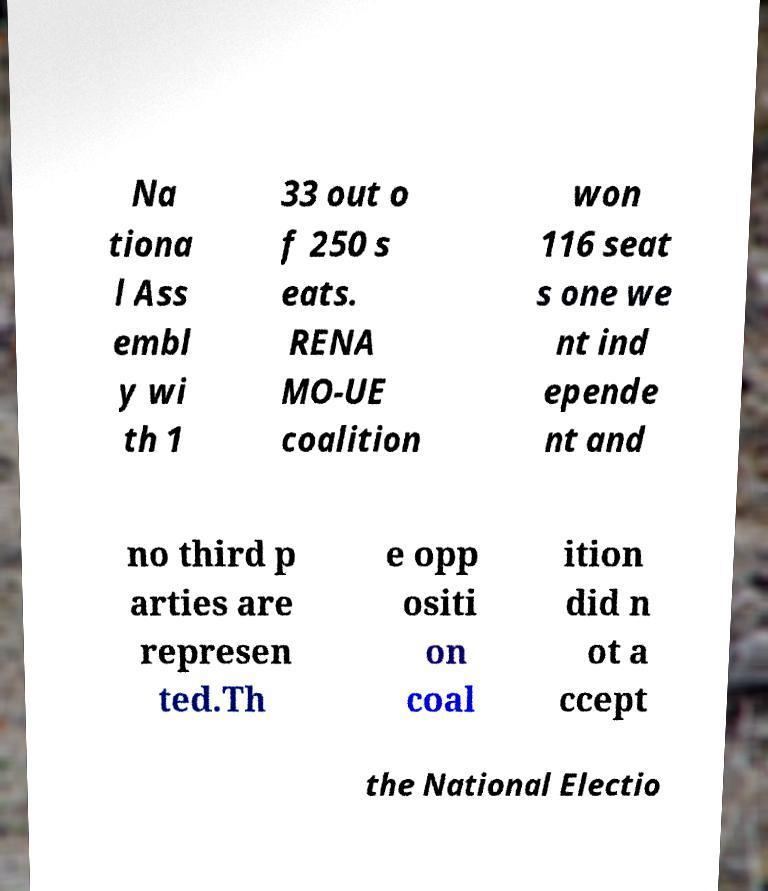Could you assist in decoding the text presented in this image and type it out clearly? Na tiona l Ass embl y wi th 1 33 out o f 250 s eats. RENA MO-UE coalition won 116 seat s one we nt ind epende nt and no third p arties are represen ted.Th e opp ositi on coal ition did n ot a ccept the National Electio 